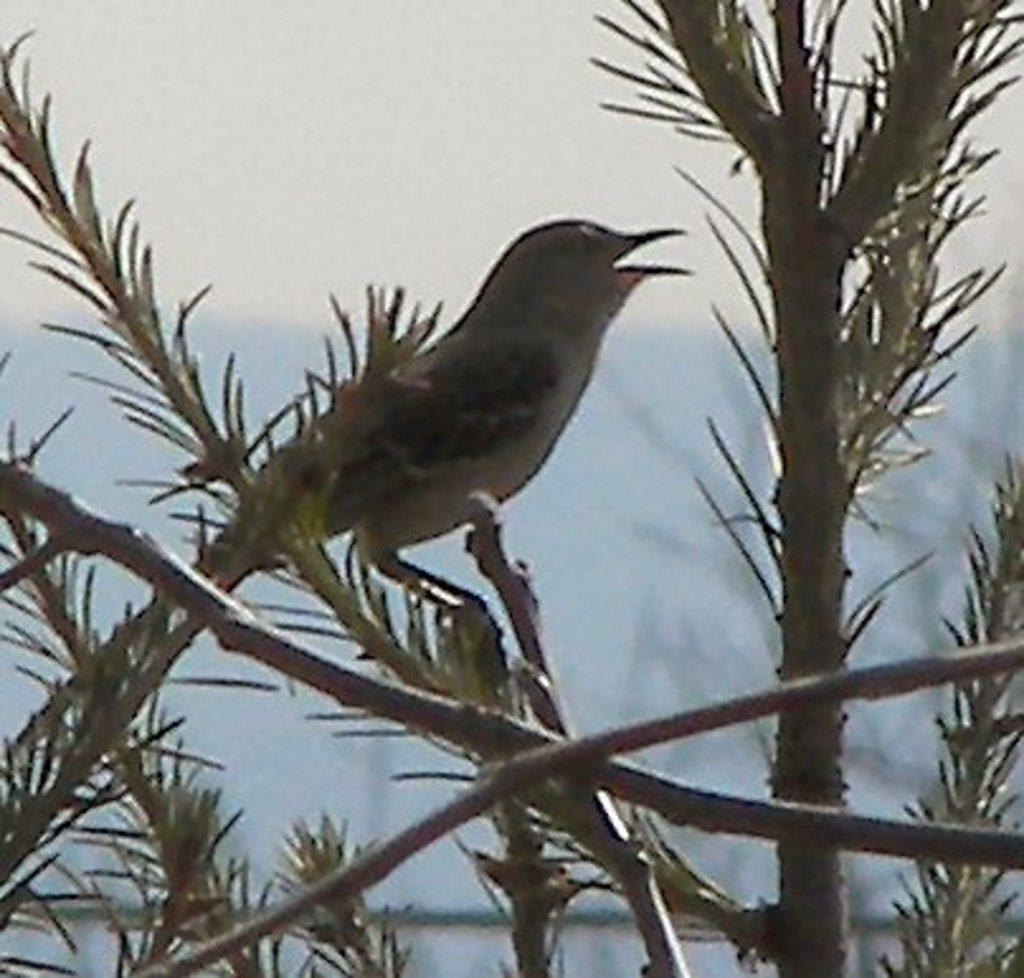In one or two sentences, can you explain what this image depicts? In this picture we can see a bird standing on a branch of a tree. 